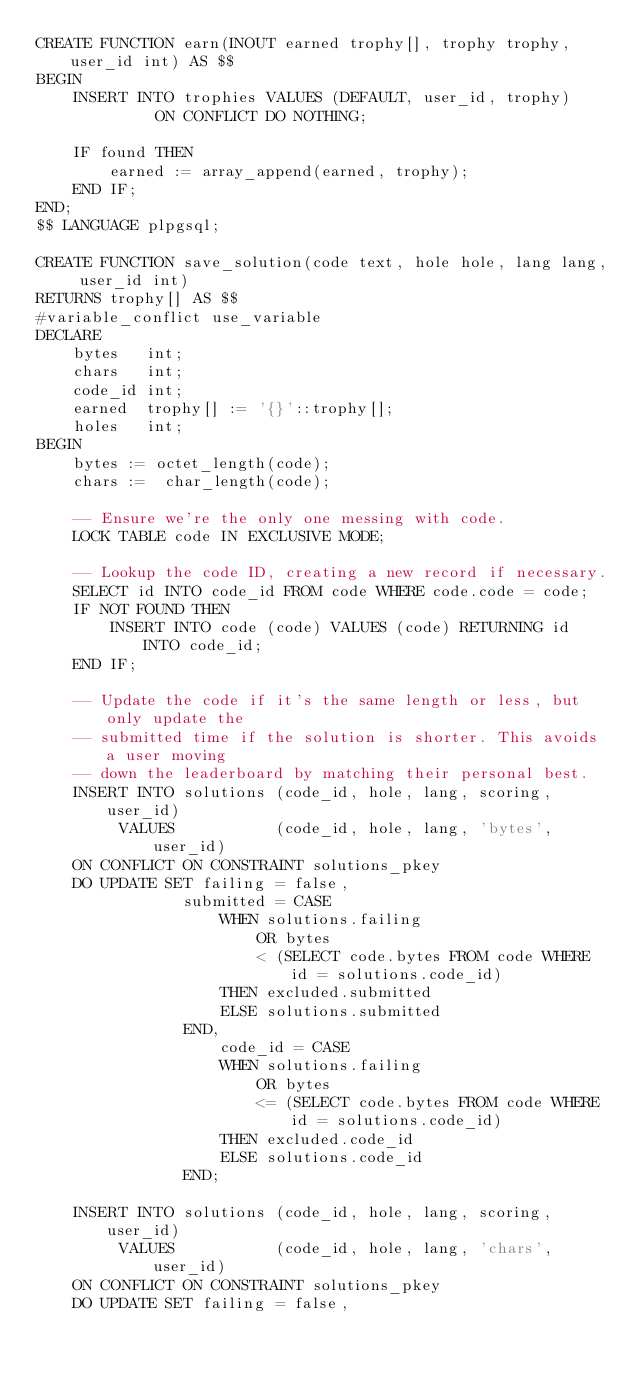<code> <loc_0><loc_0><loc_500><loc_500><_SQL_>CREATE FUNCTION earn(INOUT earned trophy[], trophy trophy, user_id int) AS $$
BEGIN
    INSERT INTO trophies VALUES (DEFAULT, user_id, trophy)
             ON CONFLICT DO NOTHING;

    IF found THEN
        earned := array_append(earned, trophy);
    END IF;
END;
$$ LANGUAGE plpgsql;

CREATE FUNCTION save_solution(code text, hole hole, lang lang, user_id int)
RETURNS trophy[] AS $$
#variable_conflict use_variable
DECLARE
    bytes   int;
    chars   int;
    code_id int;
    earned  trophy[] := '{}'::trophy[];
    holes   int;
BEGIN
    bytes := octet_length(code);
    chars :=  char_length(code);

    -- Ensure we're the only one messing with code.
    LOCK TABLE code IN EXCLUSIVE MODE;

    -- Lookup the code ID, creating a new record if necessary.
    SELECT id INTO code_id FROM code WHERE code.code = code;
    IF NOT FOUND THEN
        INSERT INTO code (code) VALUES (code) RETURNING id INTO code_id;
    END IF;

    -- Update the code if it's the same length or less, but only update the
    -- submitted time if the solution is shorter. This avoids a user moving
    -- down the leaderboard by matching their personal best.
    INSERT INTO solutions (code_id, hole, lang, scoring, user_id)
         VALUES           (code_id, hole, lang, 'bytes', user_id)
    ON CONFLICT ON CONSTRAINT solutions_pkey
    DO UPDATE SET failing = false,
                submitted = CASE
                    WHEN solutions.failing
                        OR bytes
                        < (SELECT code.bytes FROM code WHERE id = solutions.code_id)
                    THEN excluded.submitted
                    ELSE solutions.submitted
                END,
                    code_id = CASE
                    WHEN solutions.failing
                        OR bytes
                        <= (SELECT code.bytes FROM code WHERE id = solutions.code_id)
                    THEN excluded.code_id
                    ELSE solutions.code_id
                END;

    INSERT INTO solutions (code_id, hole, lang, scoring, user_id)
         VALUES           (code_id, hole, lang, 'chars', user_id)
    ON CONFLICT ON CONSTRAINT solutions_pkey
    DO UPDATE SET failing = false,</code> 